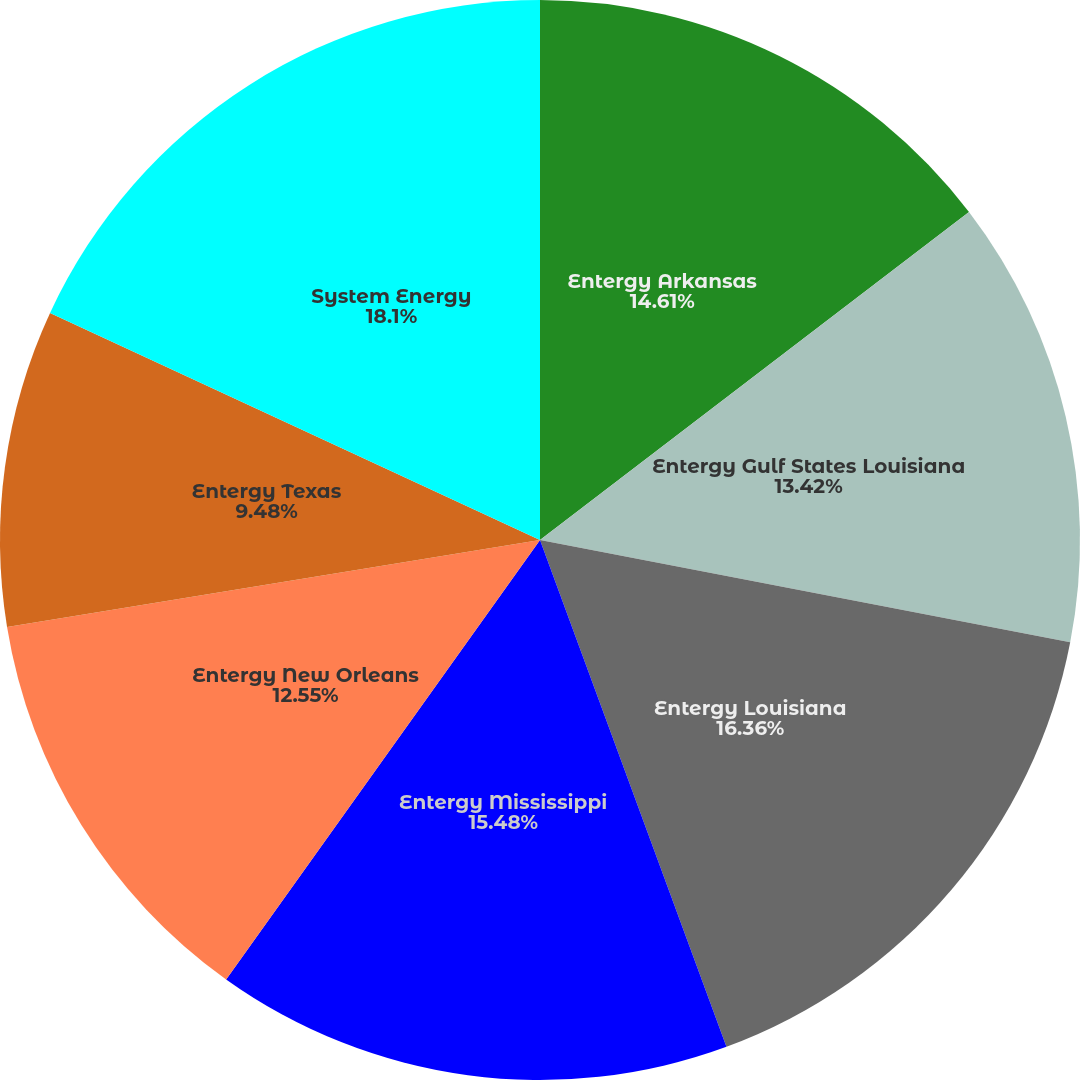Convert chart. <chart><loc_0><loc_0><loc_500><loc_500><pie_chart><fcel>Entergy Arkansas<fcel>Entergy Gulf States Louisiana<fcel>Entergy Louisiana<fcel>Entergy Mississippi<fcel>Entergy New Orleans<fcel>Entergy Texas<fcel>System Energy<nl><fcel>14.61%<fcel>13.42%<fcel>16.35%<fcel>15.48%<fcel>12.55%<fcel>9.48%<fcel>18.09%<nl></chart> 